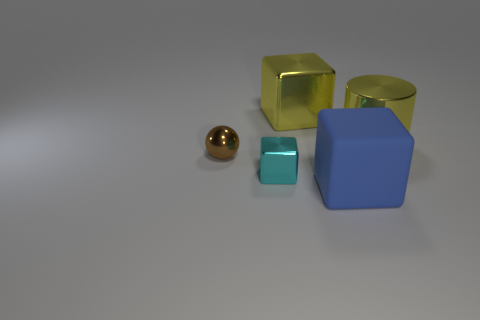Subtract all large matte blocks. How many blocks are left? 2 Subtract 2 blocks. How many blocks are left? 1 Add 5 large cyan metal spheres. How many objects exist? 10 Subtract all blue cubes. How many cubes are left? 2 Subtract all cylinders. How many objects are left? 4 Subtract 0 red blocks. How many objects are left? 5 Subtract all gray balls. Subtract all green blocks. How many balls are left? 1 Subtract all cyan things. Subtract all large yellow blocks. How many objects are left? 3 Add 4 tiny cyan blocks. How many tiny cyan blocks are left? 5 Add 1 tiny cubes. How many tiny cubes exist? 2 